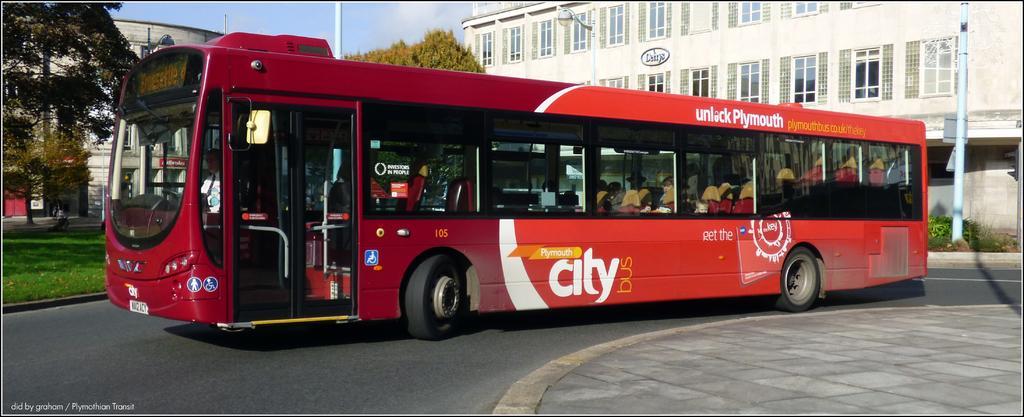How would you summarize this image in a sentence or two? In this image I can see a bus. I can see a tree. In the background there is a building. I can see some clouds in the sky. 